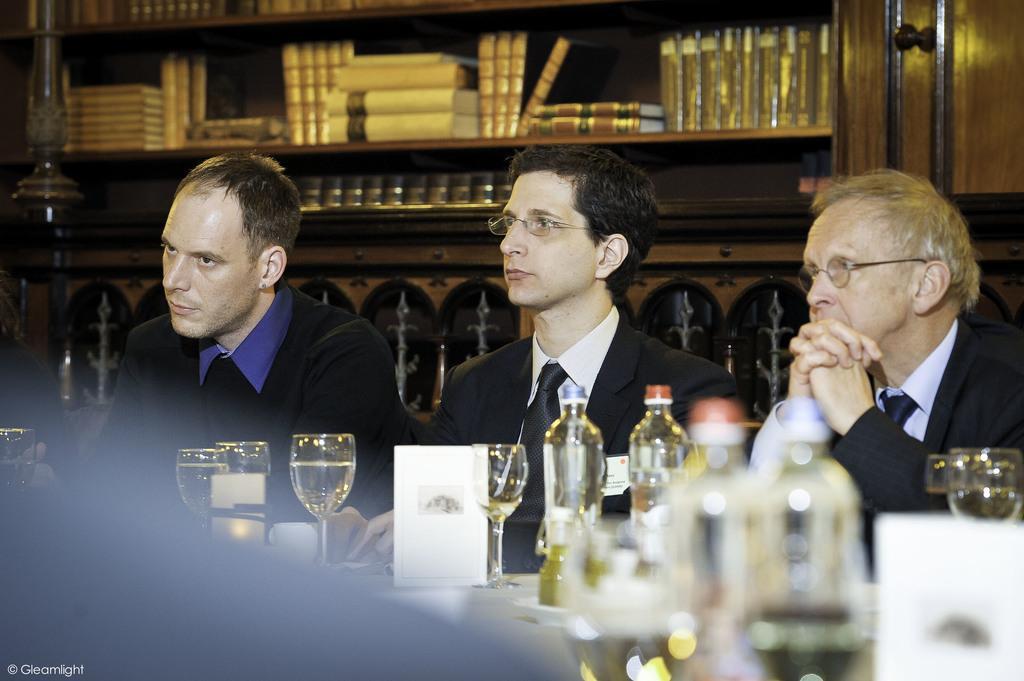Can you describe this image briefly? In this image we can see some group of persons wearing black color dress sitting on chairs and there are some glasses, bottles and some objects on the table and in the background of the image there are some books arranged in the shelves and there is a wardrobe. 